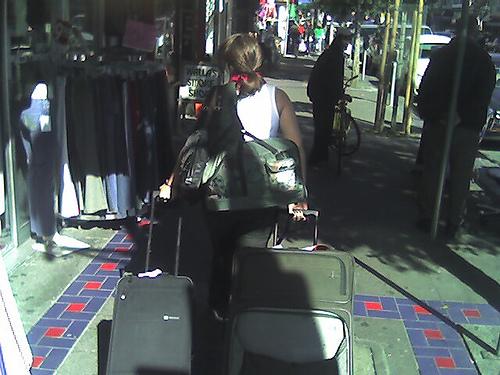How many bags is the woman carrying?
Write a very short answer. 4. What color are the tiles on the ground?
Keep it brief. Blue and red. Is it night time?
Quick response, please. No. 